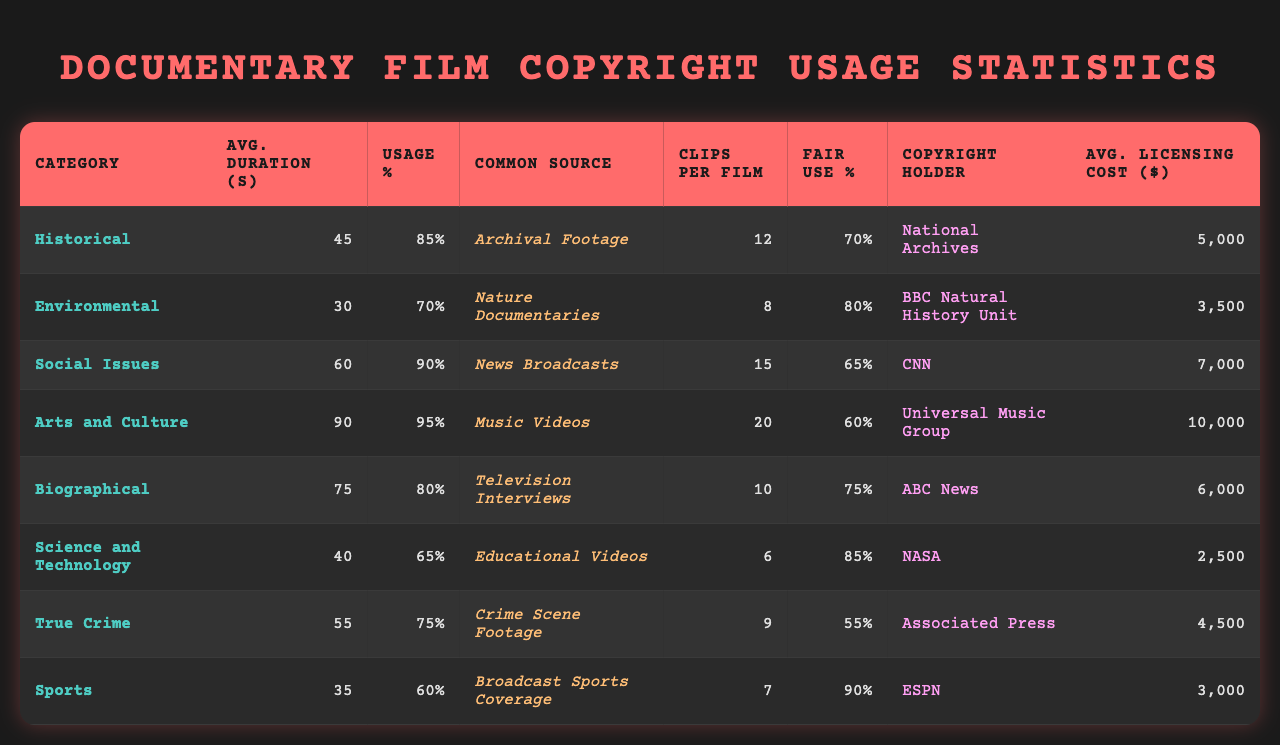What is the most common source of copyrighted material in documentary films about social issues? The table indicates that the most common source for social issues documentaries is "News Broadcasts." This is directly retrieved from the relevant column in the table under the category of Social Issues.
Answer: News Broadcasts Which documentary category has the highest percentage of films using copyrighted material? According to the table, the highest percentage of films using copyrighted material is found in the Arts and Culture category, which is 95%. This is derived from comparing the percentages across all categories in the table.
Answer: Arts and Culture What is the average duration of copyrighted material used in environmental documentaries? The average duration for environmental documentaries is listed as 30 seconds in the corresponding entry in the table under Average Duration of Copyrighted Material.
Answer: 30 seconds How many average clips are used per film in true crime documentaries compared to historical documentaries? True crime documentaries average 9 clips per film, while historical documentaries average 12. The comparison is made by retrieving the averages from the 'Average Number of Copyrighted Clips per Film' column for both categories.
Answer: 9 vs. 12 What percentage of films in the biographical category is cleared for fair use? The table shows that 75% of films in the biographical category are cleared for fair use, which is directly retrieved from the 'Percentage Cleared for Fair Use' column.
Answer: 75% Calculate the average cost of licensing for documentaries about historical and environmental topics combined. The average cost for historical documentaries is $5,000 and for environmental documentaries is $3,500. Therefore, the combined average cost is (5000 + 3500) / 2 = $4,250.
Answer: $4,250 Do most documentaries on science and technology use copyrighted material? The data shows that 65% of science and technology documentaries use copyrighted material, which confirms that it is indeed more than half. Thus, the answer is yes, they do use copyrighted material.
Answer: Yes Which category has the lowest average cost of licensing per film? The table indicates that the science and technology category has the lowest average licensing cost at $2,500, which can be determined by scanning the 'Average Cost of Licensing per Film ($)' column for the lowest value.
Answer: $2,500 Are environmental documentaries typically more expensive to license compared to sports documentaries? Environmental documentaries have an average cost of $3,500 while sports documentaries are at $3,000. Comparing these values confirms that environmental documentaries are indeed more expensive to license.
Answer: Yes What is the total average duration of copyrighted material from all categories? The total average duration is calculated by summing the average durations of all categories and then dividing by the number of categories: (45 + 30 + 60 + 90 + 75 + 40 + 55 + 35) / 8 = 52.5 seconds.
Answer: 52.5 seconds 